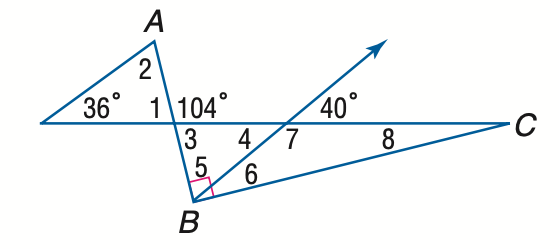Question: Find the measure of \angle 8 if A B \perp B C.
Choices:
A. 14
B. 15
C. 16
D. 17
Answer with the letter. Answer: A Question: Find the measure of \angle 1 if A B \perp B C.
Choices:
A. 64
B. 68
C. 72
D. 76
Answer with the letter. Answer: D Question: Find the measure of \angle 6 if A B \perp B C.
Choices:
A. 21
B. 26
C. 31
D. 36
Answer with the letter. Answer: B Question: Find the measure of \angle 4 if A B \perp B C.
Choices:
A. 36
B. 38
C. 40
D. 42
Answer with the letter. Answer: C Question: Find the measure of \angle 7 if A B \perp B C.
Choices:
A. 110
B. 120
C. 130
D. 140
Answer with the letter. Answer: D 